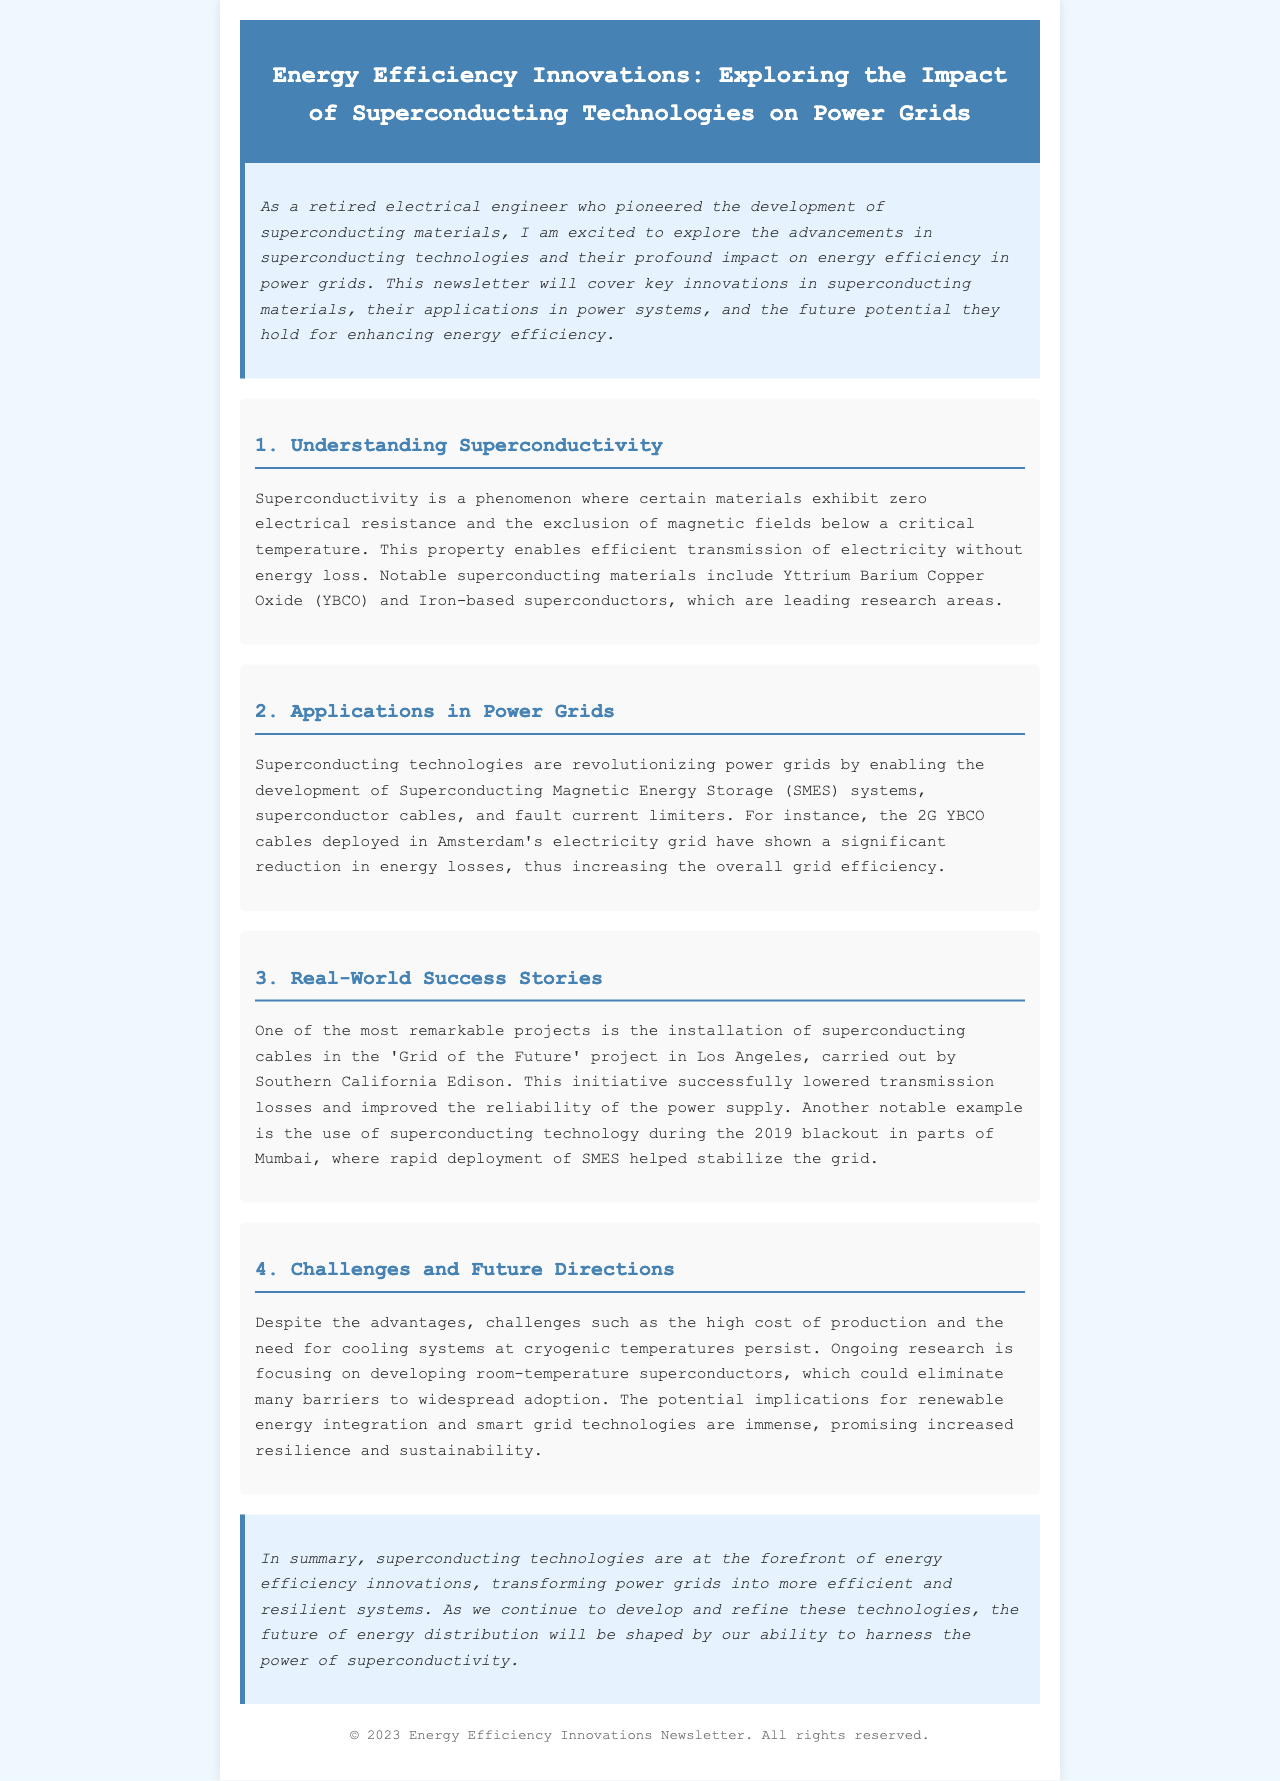What is the main topic of the newsletter? The main topic discussed in the newsletter is energy efficiency innovations related to superconducting technologies and their impact on power grids.
Answer: Energy Efficiency Innovations: Exploring the Impact of Superconducting Technologies on Power Grids Which superconducting material is notably mentioned in the document? The document highlights Yttrium Barium Copper Oxide (YBCO) as one of the notable superconducting materials.
Answer: Yttrium Barium Copper Oxide (YBCO) What application of superconducting technologies is highlighted in Amsterdam? The document describes the deployment of 2G YBCO cables in Amsterdam’s electricity grid as a specific application.
Answer: 2G YBCO cables Which project is mentioned as enhancing reliability in Los Angeles? The installation of superconducting cables in the 'Grid of the Future' project by Southern California Edison is identified.
Answer: Grid of the Future What major challenge for superconducting technologies does the document mention? The high cost of production is listed as a significant challenge in the adoption of superconducting technologies.
Answer: High cost of production What is the future research focus stated in the newsletter? The current research focus is on developing room-temperature superconductors to overcome existing limitations.
Answer: Room-temperature superconductors Which event did the superconducting technology help stabilize in Mumbai? The document refers to the 2019 blackout in parts of Mumbai where SMES helped to stabilize the grid.
Answer: 2019 blackout Where can feedback for the newsletter be directed? The footer typically indicates the rights reserved and may imply where to direct feedback, but specifics are not provided in the document.
Answer: Not specified 